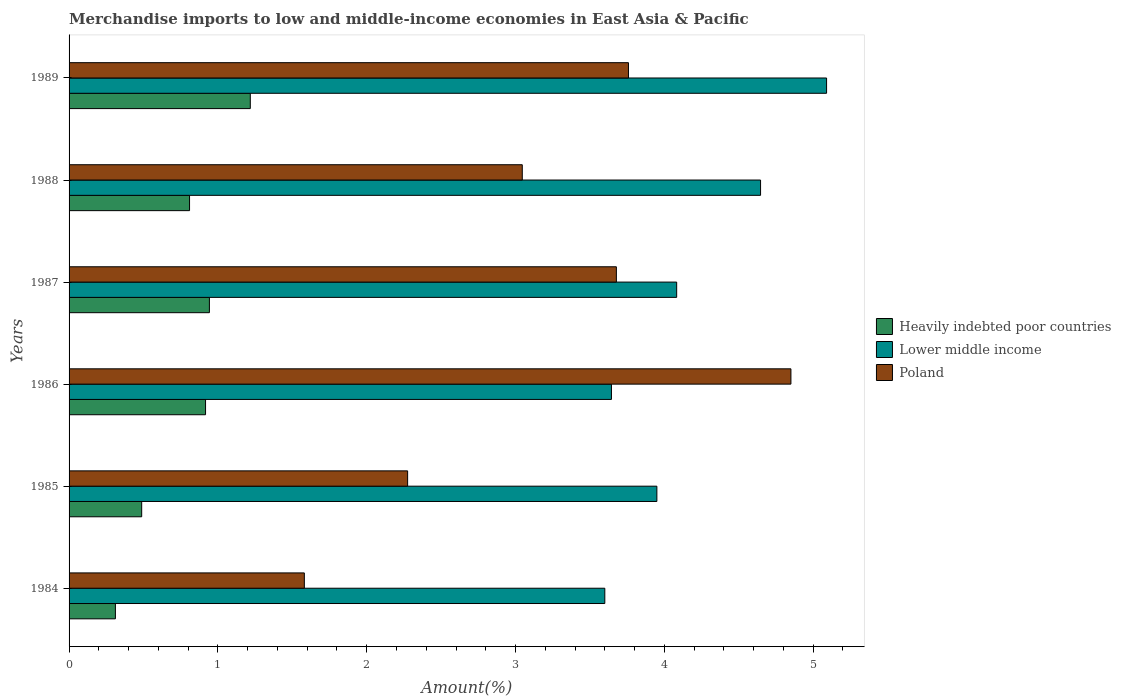Are the number of bars per tick equal to the number of legend labels?
Provide a succinct answer. Yes. How many bars are there on the 4th tick from the top?
Keep it short and to the point. 3. What is the label of the 2nd group of bars from the top?
Keep it short and to the point. 1988. What is the percentage of amount earned from merchandise imports in Lower middle income in 1985?
Your answer should be very brief. 3.95. Across all years, what is the maximum percentage of amount earned from merchandise imports in Lower middle income?
Keep it short and to the point. 5.09. Across all years, what is the minimum percentage of amount earned from merchandise imports in Lower middle income?
Make the answer very short. 3.6. What is the total percentage of amount earned from merchandise imports in Poland in the graph?
Ensure brevity in your answer.  19.19. What is the difference between the percentage of amount earned from merchandise imports in Poland in 1986 and that in 1988?
Your answer should be compact. 1.81. What is the difference between the percentage of amount earned from merchandise imports in Heavily indebted poor countries in 1988 and the percentage of amount earned from merchandise imports in Poland in 1989?
Offer a terse response. -2.95. What is the average percentage of amount earned from merchandise imports in Lower middle income per year?
Provide a short and direct response. 4.17. In the year 1987, what is the difference between the percentage of amount earned from merchandise imports in Heavily indebted poor countries and percentage of amount earned from merchandise imports in Lower middle income?
Offer a very short reply. -3.14. In how many years, is the percentage of amount earned from merchandise imports in Lower middle income greater than 4.8 %?
Provide a succinct answer. 1. What is the ratio of the percentage of amount earned from merchandise imports in Heavily indebted poor countries in 1984 to that in 1987?
Keep it short and to the point. 0.33. Is the percentage of amount earned from merchandise imports in Heavily indebted poor countries in 1985 less than that in 1987?
Your answer should be compact. Yes. Is the difference between the percentage of amount earned from merchandise imports in Heavily indebted poor countries in 1988 and 1989 greater than the difference between the percentage of amount earned from merchandise imports in Lower middle income in 1988 and 1989?
Offer a terse response. Yes. What is the difference between the highest and the second highest percentage of amount earned from merchandise imports in Heavily indebted poor countries?
Ensure brevity in your answer.  0.27. What is the difference between the highest and the lowest percentage of amount earned from merchandise imports in Lower middle income?
Offer a terse response. 1.49. In how many years, is the percentage of amount earned from merchandise imports in Heavily indebted poor countries greater than the average percentage of amount earned from merchandise imports in Heavily indebted poor countries taken over all years?
Keep it short and to the point. 4. What does the 3rd bar from the top in 1987 represents?
Offer a terse response. Heavily indebted poor countries. How many years are there in the graph?
Provide a succinct answer. 6. What is the difference between two consecutive major ticks on the X-axis?
Keep it short and to the point. 1. Are the values on the major ticks of X-axis written in scientific E-notation?
Your answer should be very brief. No. Does the graph contain any zero values?
Your answer should be very brief. No. What is the title of the graph?
Make the answer very short. Merchandise imports to low and middle-income economies in East Asia & Pacific. What is the label or title of the X-axis?
Keep it short and to the point. Amount(%). What is the Amount(%) of Heavily indebted poor countries in 1984?
Offer a terse response. 0.31. What is the Amount(%) in Lower middle income in 1984?
Keep it short and to the point. 3.6. What is the Amount(%) of Poland in 1984?
Your answer should be compact. 1.58. What is the Amount(%) in Heavily indebted poor countries in 1985?
Your response must be concise. 0.49. What is the Amount(%) in Lower middle income in 1985?
Provide a succinct answer. 3.95. What is the Amount(%) of Poland in 1985?
Keep it short and to the point. 2.27. What is the Amount(%) in Heavily indebted poor countries in 1986?
Your response must be concise. 0.92. What is the Amount(%) of Lower middle income in 1986?
Ensure brevity in your answer.  3.64. What is the Amount(%) of Poland in 1986?
Make the answer very short. 4.85. What is the Amount(%) in Heavily indebted poor countries in 1987?
Provide a short and direct response. 0.94. What is the Amount(%) of Lower middle income in 1987?
Your response must be concise. 4.08. What is the Amount(%) of Poland in 1987?
Ensure brevity in your answer.  3.68. What is the Amount(%) of Heavily indebted poor countries in 1988?
Keep it short and to the point. 0.81. What is the Amount(%) of Lower middle income in 1988?
Make the answer very short. 4.65. What is the Amount(%) of Poland in 1988?
Make the answer very short. 3.05. What is the Amount(%) of Heavily indebted poor countries in 1989?
Give a very brief answer. 1.22. What is the Amount(%) in Lower middle income in 1989?
Make the answer very short. 5.09. What is the Amount(%) in Poland in 1989?
Your answer should be compact. 3.76. Across all years, what is the maximum Amount(%) of Heavily indebted poor countries?
Ensure brevity in your answer.  1.22. Across all years, what is the maximum Amount(%) of Lower middle income?
Keep it short and to the point. 5.09. Across all years, what is the maximum Amount(%) of Poland?
Ensure brevity in your answer.  4.85. Across all years, what is the minimum Amount(%) in Heavily indebted poor countries?
Keep it short and to the point. 0.31. Across all years, what is the minimum Amount(%) of Lower middle income?
Your response must be concise. 3.6. Across all years, what is the minimum Amount(%) in Poland?
Ensure brevity in your answer.  1.58. What is the total Amount(%) of Heavily indebted poor countries in the graph?
Give a very brief answer. 4.69. What is the total Amount(%) of Lower middle income in the graph?
Your answer should be compact. 25.01. What is the total Amount(%) in Poland in the graph?
Keep it short and to the point. 19.19. What is the difference between the Amount(%) of Heavily indebted poor countries in 1984 and that in 1985?
Ensure brevity in your answer.  -0.18. What is the difference between the Amount(%) of Lower middle income in 1984 and that in 1985?
Make the answer very short. -0.35. What is the difference between the Amount(%) of Poland in 1984 and that in 1985?
Your response must be concise. -0.69. What is the difference between the Amount(%) in Heavily indebted poor countries in 1984 and that in 1986?
Your answer should be compact. -0.61. What is the difference between the Amount(%) of Lower middle income in 1984 and that in 1986?
Give a very brief answer. -0.04. What is the difference between the Amount(%) in Poland in 1984 and that in 1986?
Offer a terse response. -3.27. What is the difference between the Amount(%) of Heavily indebted poor countries in 1984 and that in 1987?
Offer a terse response. -0.63. What is the difference between the Amount(%) of Lower middle income in 1984 and that in 1987?
Keep it short and to the point. -0.48. What is the difference between the Amount(%) in Poland in 1984 and that in 1987?
Give a very brief answer. -2.1. What is the difference between the Amount(%) of Heavily indebted poor countries in 1984 and that in 1988?
Ensure brevity in your answer.  -0.5. What is the difference between the Amount(%) in Lower middle income in 1984 and that in 1988?
Make the answer very short. -1.05. What is the difference between the Amount(%) of Poland in 1984 and that in 1988?
Provide a succinct answer. -1.46. What is the difference between the Amount(%) in Heavily indebted poor countries in 1984 and that in 1989?
Your answer should be compact. -0.91. What is the difference between the Amount(%) of Lower middle income in 1984 and that in 1989?
Provide a succinct answer. -1.49. What is the difference between the Amount(%) of Poland in 1984 and that in 1989?
Offer a very short reply. -2.18. What is the difference between the Amount(%) in Heavily indebted poor countries in 1985 and that in 1986?
Provide a short and direct response. -0.43. What is the difference between the Amount(%) in Lower middle income in 1985 and that in 1986?
Your answer should be compact. 0.31. What is the difference between the Amount(%) in Poland in 1985 and that in 1986?
Make the answer very short. -2.58. What is the difference between the Amount(%) of Heavily indebted poor countries in 1985 and that in 1987?
Provide a succinct answer. -0.46. What is the difference between the Amount(%) in Lower middle income in 1985 and that in 1987?
Ensure brevity in your answer.  -0.13. What is the difference between the Amount(%) of Poland in 1985 and that in 1987?
Give a very brief answer. -1.4. What is the difference between the Amount(%) of Heavily indebted poor countries in 1985 and that in 1988?
Make the answer very short. -0.32. What is the difference between the Amount(%) of Lower middle income in 1985 and that in 1988?
Provide a succinct answer. -0.7. What is the difference between the Amount(%) in Poland in 1985 and that in 1988?
Make the answer very short. -0.77. What is the difference between the Amount(%) in Heavily indebted poor countries in 1985 and that in 1989?
Offer a very short reply. -0.73. What is the difference between the Amount(%) in Lower middle income in 1985 and that in 1989?
Make the answer very short. -1.14. What is the difference between the Amount(%) in Poland in 1985 and that in 1989?
Your answer should be compact. -1.48. What is the difference between the Amount(%) of Heavily indebted poor countries in 1986 and that in 1987?
Ensure brevity in your answer.  -0.03. What is the difference between the Amount(%) in Lower middle income in 1986 and that in 1987?
Provide a succinct answer. -0.44. What is the difference between the Amount(%) of Poland in 1986 and that in 1987?
Your answer should be very brief. 1.17. What is the difference between the Amount(%) of Heavily indebted poor countries in 1986 and that in 1988?
Offer a terse response. 0.11. What is the difference between the Amount(%) in Lower middle income in 1986 and that in 1988?
Offer a terse response. -1. What is the difference between the Amount(%) in Poland in 1986 and that in 1988?
Provide a short and direct response. 1.81. What is the difference between the Amount(%) in Heavily indebted poor countries in 1986 and that in 1989?
Your answer should be very brief. -0.3. What is the difference between the Amount(%) of Lower middle income in 1986 and that in 1989?
Keep it short and to the point. -1.45. What is the difference between the Amount(%) of Poland in 1986 and that in 1989?
Provide a short and direct response. 1.09. What is the difference between the Amount(%) of Heavily indebted poor countries in 1987 and that in 1988?
Make the answer very short. 0.13. What is the difference between the Amount(%) of Lower middle income in 1987 and that in 1988?
Keep it short and to the point. -0.56. What is the difference between the Amount(%) of Poland in 1987 and that in 1988?
Provide a short and direct response. 0.63. What is the difference between the Amount(%) of Heavily indebted poor countries in 1987 and that in 1989?
Ensure brevity in your answer.  -0.27. What is the difference between the Amount(%) of Lower middle income in 1987 and that in 1989?
Your answer should be compact. -1.01. What is the difference between the Amount(%) in Poland in 1987 and that in 1989?
Make the answer very short. -0.08. What is the difference between the Amount(%) in Heavily indebted poor countries in 1988 and that in 1989?
Provide a short and direct response. -0.41. What is the difference between the Amount(%) of Lower middle income in 1988 and that in 1989?
Ensure brevity in your answer.  -0.44. What is the difference between the Amount(%) in Poland in 1988 and that in 1989?
Provide a succinct answer. -0.71. What is the difference between the Amount(%) of Heavily indebted poor countries in 1984 and the Amount(%) of Lower middle income in 1985?
Your answer should be very brief. -3.64. What is the difference between the Amount(%) in Heavily indebted poor countries in 1984 and the Amount(%) in Poland in 1985?
Offer a terse response. -1.96. What is the difference between the Amount(%) of Lower middle income in 1984 and the Amount(%) of Poland in 1985?
Offer a very short reply. 1.32. What is the difference between the Amount(%) of Heavily indebted poor countries in 1984 and the Amount(%) of Lower middle income in 1986?
Offer a terse response. -3.33. What is the difference between the Amount(%) in Heavily indebted poor countries in 1984 and the Amount(%) in Poland in 1986?
Keep it short and to the point. -4.54. What is the difference between the Amount(%) of Lower middle income in 1984 and the Amount(%) of Poland in 1986?
Provide a succinct answer. -1.25. What is the difference between the Amount(%) in Heavily indebted poor countries in 1984 and the Amount(%) in Lower middle income in 1987?
Make the answer very short. -3.77. What is the difference between the Amount(%) of Heavily indebted poor countries in 1984 and the Amount(%) of Poland in 1987?
Give a very brief answer. -3.37. What is the difference between the Amount(%) of Lower middle income in 1984 and the Amount(%) of Poland in 1987?
Ensure brevity in your answer.  -0.08. What is the difference between the Amount(%) in Heavily indebted poor countries in 1984 and the Amount(%) in Lower middle income in 1988?
Provide a short and direct response. -4.34. What is the difference between the Amount(%) of Heavily indebted poor countries in 1984 and the Amount(%) of Poland in 1988?
Keep it short and to the point. -2.73. What is the difference between the Amount(%) in Lower middle income in 1984 and the Amount(%) in Poland in 1988?
Give a very brief answer. 0.55. What is the difference between the Amount(%) of Heavily indebted poor countries in 1984 and the Amount(%) of Lower middle income in 1989?
Your answer should be very brief. -4.78. What is the difference between the Amount(%) in Heavily indebted poor countries in 1984 and the Amount(%) in Poland in 1989?
Provide a succinct answer. -3.45. What is the difference between the Amount(%) in Lower middle income in 1984 and the Amount(%) in Poland in 1989?
Your answer should be compact. -0.16. What is the difference between the Amount(%) of Heavily indebted poor countries in 1985 and the Amount(%) of Lower middle income in 1986?
Make the answer very short. -3.16. What is the difference between the Amount(%) of Heavily indebted poor countries in 1985 and the Amount(%) of Poland in 1986?
Keep it short and to the point. -4.36. What is the difference between the Amount(%) in Lower middle income in 1985 and the Amount(%) in Poland in 1986?
Offer a very short reply. -0.9. What is the difference between the Amount(%) of Heavily indebted poor countries in 1985 and the Amount(%) of Lower middle income in 1987?
Provide a short and direct response. -3.59. What is the difference between the Amount(%) in Heavily indebted poor countries in 1985 and the Amount(%) in Poland in 1987?
Ensure brevity in your answer.  -3.19. What is the difference between the Amount(%) in Lower middle income in 1985 and the Amount(%) in Poland in 1987?
Keep it short and to the point. 0.27. What is the difference between the Amount(%) in Heavily indebted poor countries in 1985 and the Amount(%) in Lower middle income in 1988?
Provide a succinct answer. -4.16. What is the difference between the Amount(%) of Heavily indebted poor countries in 1985 and the Amount(%) of Poland in 1988?
Your answer should be very brief. -2.56. What is the difference between the Amount(%) in Lower middle income in 1985 and the Amount(%) in Poland in 1988?
Provide a short and direct response. 0.9. What is the difference between the Amount(%) in Heavily indebted poor countries in 1985 and the Amount(%) in Lower middle income in 1989?
Offer a terse response. -4.6. What is the difference between the Amount(%) of Heavily indebted poor countries in 1985 and the Amount(%) of Poland in 1989?
Offer a very short reply. -3.27. What is the difference between the Amount(%) of Lower middle income in 1985 and the Amount(%) of Poland in 1989?
Ensure brevity in your answer.  0.19. What is the difference between the Amount(%) of Heavily indebted poor countries in 1986 and the Amount(%) of Lower middle income in 1987?
Make the answer very short. -3.17. What is the difference between the Amount(%) of Heavily indebted poor countries in 1986 and the Amount(%) of Poland in 1987?
Offer a very short reply. -2.76. What is the difference between the Amount(%) of Lower middle income in 1986 and the Amount(%) of Poland in 1987?
Your answer should be very brief. -0.03. What is the difference between the Amount(%) in Heavily indebted poor countries in 1986 and the Amount(%) in Lower middle income in 1988?
Provide a succinct answer. -3.73. What is the difference between the Amount(%) of Heavily indebted poor countries in 1986 and the Amount(%) of Poland in 1988?
Keep it short and to the point. -2.13. What is the difference between the Amount(%) in Lower middle income in 1986 and the Amount(%) in Poland in 1988?
Provide a succinct answer. 0.6. What is the difference between the Amount(%) in Heavily indebted poor countries in 1986 and the Amount(%) in Lower middle income in 1989?
Your answer should be compact. -4.17. What is the difference between the Amount(%) in Heavily indebted poor countries in 1986 and the Amount(%) in Poland in 1989?
Make the answer very short. -2.84. What is the difference between the Amount(%) in Lower middle income in 1986 and the Amount(%) in Poland in 1989?
Your answer should be very brief. -0.11. What is the difference between the Amount(%) of Heavily indebted poor countries in 1987 and the Amount(%) of Lower middle income in 1988?
Your answer should be very brief. -3.7. What is the difference between the Amount(%) of Heavily indebted poor countries in 1987 and the Amount(%) of Poland in 1988?
Provide a succinct answer. -2.1. What is the difference between the Amount(%) of Lower middle income in 1987 and the Amount(%) of Poland in 1988?
Offer a very short reply. 1.04. What is the difference between the Amount(%) of Heavily indebted poor countries in 1987 and the Amount(%) of Lower middle income in 1989?
Give a very brief answer. -4.15. What is the difference between the Amount(%) in Heavily indebted poor countries in 1987 and the Amount(%) in Poland in 1989?
Your answer should be very brief. -2.82. What is the difference between the Amount(%) of Lower middle income in 1987 and the Amount(%) of Poland in 1989?
Provide a short and direct response. 0.32. What is the difference between the Amount(%) in Heavily indebted poor countries in 1988 and the Amount(%) in Lower middle income in 1989?
Offer a very short reply. -4.28. What is the difference between the Amount(%) in Heavily indebted poor countries in 1988 and the Amount(%) in Poland in 1989?
Give a very brief answer. -2.95. What is the difference between the Amount(%) in Lower middle income in 1988 and the Amount(%) in Poland in 1989?
Make the answer very short. 0.89. What is the average Amount(%) of Heavily indebted poor countries per year?
Your answer should be very brief. 0.78. What is the average Amount(%) of Lower middle income per year?
Keep it short and to the point. 4.17. What is the average Amount(%) in Poland per year?
Give a very brief answer. 3.2. In the year 1984, what is the difference between the Amount(%) of Heavily indebted poor countries and Amount(%) of Lower middle income?
Your response must be concise. -3.29. In the year 1984, what is the difference between the Amount(%) in Heavily indebted poor countries and Amount(%) in Poland?
Your answer should be compact. -1.27. In the year 1984, what is the difference between the Amount(%) of Lower middle income and Amount(%) of Poland?
Your response must be concise. 2.02. In the year 1985, what is the difference between the Amount(%) in Heavily indebted poor countries and Amount(%) in Lower middle income?
Provide a short and direct response. -3.46. In the year 1985, what is the difference between the Amount(%) in Heavily indebted poor countries and Amount(%) in Poland?
Make the answer very short. -1.79. In the year 1985, what is the difference between the Amount(%) of Lower middle income and Amount(%) of Poland?
Ensure brevity in your answer.  1.67. In the year 1986, what is the difference between the Amount(%) of Heavily indebted poor countries and Amount(%) of Lower middle income?
Your answer should be compact. -2.73. In the year 1986, what is the difference between the Amount(%) of Heavily indebted poor countries and Amount(%) of Poland?
Your answer should be compact. -3.93. In the year 1986, what is the difference between the Amount(%) of Lower middle income and Amount(%) of Poland?
Your answer should be compact. -1.21. In the year 1987, what is the difference between the Amount(%) in Heavily indebted poor countries and Amount(%) in Lower middle income?
Make the answer very short. -3.14. In the year 1987, what is the difference between the Amount(%) in Heavily indebted poor countries and Amount(%) in Poland?
Your response must be concise. -2.73. In the year 1987, what is the difference between the Amount(%) of Lower middle income and Amount(%) of Poland?
Offer a very short reply. 0.41. In the year 1988, what is the difference between the Amount(%) of Heavily indebted poor countries and Amount(%) of Lower middle income?
Offer a terse response. -3.84. In the year 1988, what is the difference between the Amount(%) in Heavily indebted poor countries and Amount(%) in Poland?
Provide a short and direct response. -2.24. In the year 1988, what is the difference between the Amount(%) of Lower middle income and Amount(%) of Poland?
Give a very brief answer. 1.6. In the year 1989, what is the difference between the Amount(%) of Heavily indebted poor countries and Amount(%) of Lower middle income?
Offer a very short reply. -3.87. In the year 1989, what is the difference between the Amount(%) of Heavily indebted poor countries and Amount(%) of Poland?
Keep it short and to the point. -2.54. In the year 1989, what is the difference between the Amount(%) of Lower middle income and Amount(%) of Poland?
Your response must be concise. 1.33. What is the ratio of the Amount(%) in Heavily indebted poor countries in 1984 to that in 1985?
Offer a very short reply. 0.64. What is the ratio of the Amount(%) of Lower middle income in 1984 to that in 1985?
Your answer should be very brief. 0.91. What is the ratio of the Amount(%) of Poland in 1984 to that in 1985?
Your answer should be very brief. 0.69. What is the ratio of the Amount(%) of Heavily indebted poor countries in 1984 to that in 1986?
Provide a succinct answer. 0.34. What is the ratio of the Amount(%) in Lower middle income in 1984 to that in 1986?
Your response must be concise. 0.99. What is the ratio of the Amount(%) in Poland in 1984 to that in 1986?
Provide a short and direct response. 0.33. What is the ratio of the Amount(%) in Heavily indebted poor countries in 1984 to that in 1987?
Make the answer very short. 0.33. What is the ratio of the Amount(%) of Lower middle income in 1984 to that in 1987?
Ensure brevity in your answer.  0.88. What is the ratio of the Amount(%) of Poland in 1984 to that in 1987?
Give a very brief answer. 0.43. What is the ratio of the Amount(%) in Heavily indebted poor countries in 1984 to that in 1988?
Give a very brief answer. 0.38. What is the ratio of the Amount(%) of Lower middle income in 1984 to that in 1988?
Your answer should be very brief. 0.77. What is the ratio of the Amount(%) in Poland in 1984 to that in 1988?
Provide a short and direct response. 0.52. What is the ratio of the Amount(%) of Heavily indebted poor countries in 1984 to that in 1989?
Make the answer very short. 0.26. What is the ratio of the Amount(%) of Lower middle income in 1984 to that in 1989?
Ensure brevity in your answer.  0.71. What is the ratio of the Amount(%) of Poland in 1984 to that in 1989?
Your answer should be very brief. 0.42. What is the ratio of the Amount(%) of Heavily indebted poor countries in 1985 to that in 1986?
Ensure brevity in your answer.  0.53. What is the ratio of the Amount(%) of Lower middle income in 1985 to that in 1986?
Offer a terse response. 1.08. What is the ratio of the Amount(%) in Poland in 1985 to that in 1986?
Keep it short and to the point. 0.47. What is the ratio of the Amount(%) of Heavily indebted poor countries in 1985 to that in 1987?
Provide a succinct answer. 0.52. What is the ratio of the Amount(%) of Lower middle income in 1985 to that in 1987?
Make the answer very short. 0.97. What is the ratio of the Amount(%) in Poland in 1985 to that in 1987?
Make the answer very short. 0.62. What is the ratio of the Amount(%) of Heavily indebted poor countries in 1985 to that in 1988?
Your answer should be very brief. 0.6. What is the ratio of the Amount(%) of Lower middle income in 1985 to that in 1988?
Give a very brief answer. 0.85. What is the ratio of the Amount(%) of Poland in 1985 to that in 1988?
Your response must be concise. 0.75. What is the ratio of the Amount(%) in Heavily indebted poor countries in 1985 to that in 1989?
Make the answer very short. 0.4. What is the ratio of the Amount(%) in Lower middle income in 1985 to that in 1989?
Your answer should be very brief. 0.78. What is the ratio of the Amount(%) of Poland in 1985 to that in 1989?
Offer a very short reply. 0.61. What is the ratio of the Amount(%) in Heavily indebted poor countries in 1986 to that in 1987?
Offer a terse response. 0.97. What is the ratio of the Amount(%) of Lower middle income in 1986 to that in 1987?
Make the answer very short. 0.89. What is the ratio of the Amount(%) in Poland in 1986 to that in 1987?
Ensure brevity in your answer.  1.32. What is the ratio of the Amount(%) in Heavily indebted poor countries in 1986 to that in 1988?
Your response must be concise. 1.13. What is the ratio of the Amount(%) of Lower middle income in 1986 to that in 1988?
Offer a terse response. 0.78. What is the ratio of the Amount(%) of Poland in 1986 to that in 1988?
Keep it short and to the point. 1.59. What is the ratio of the Amount(%) of Heavily indebted poor countries in 1986 to that in 1989?
Give a very brief answer. 0.75. What is the ratio of the Amount(%) of Lower middle income in 1986 to that in 1989?
Give a very brief answer. 0.72. What is the ratio of the Amount(%) of Poland in 1986 to that in 1989?
Provide a short and direct response. 1.29. What is the ratio of the Amount(%) in Heavily indebted poor countries in 1987 to that in 1988?
Keep it short and to the point. 1.16. What is the ratio of the Amount(%) in Lower middle income in 1987 to that in 1988?
Your answer should be compact. 0.88. What is the ratio of the Amount(%) in Poland in 1987 to that in 1988?
Ensure brevity in your answer.  1.21. What is the ratio of the Amount(%) of Heavily indebted poor countries in 1987 to that in 1989?
Provide a short and direct response. 0.77. What is the ratio of the Amount(%) of Lower middle income in 1987 to that in 1989?
Give a very brief answer. 0.8. What is the ratio of the Amount(%) of Poland in 1987 to that in 1989?
Your answer should be compact. 0.98. What is the ratio of the Amount(%) in Heavily indebted poor countries in 1988 to that in 1989?
Give a very brief answer. 0.66. What is the ratio of the Amount(%) of Lower middle income in 1988 to that in 1989?
Provide a succinct answer. 0.91. What is the ratio of the Amount(%) in Poland in 1988 to that in 1989?
Offer a terse response. 0.81. What is the difference between the highest and the second highest Amount(%) of Heavily indebted poor countries?
Ensure brevity in your answer.  0.27. What is the difference between the highest and the second highest Amount(%) of Lower middle income?
Provide a succinct answer. 0.44. What is the difference between the highest and the second highest Amount(%) in Poland?
Provide a short and direct response. 1.09. What is the difference between the highest and the lowest Amount(%) in Heavily indebted poor countries?
Your answer should be very brief. 0.91. What is the difference between the highest and the lowest Amount(%) in Lower middle income?
Offer a terse response. 1.49. What is the difference between the highest and the lowest Amount(%) of Poland?
Offer a terse response. 3.27. 